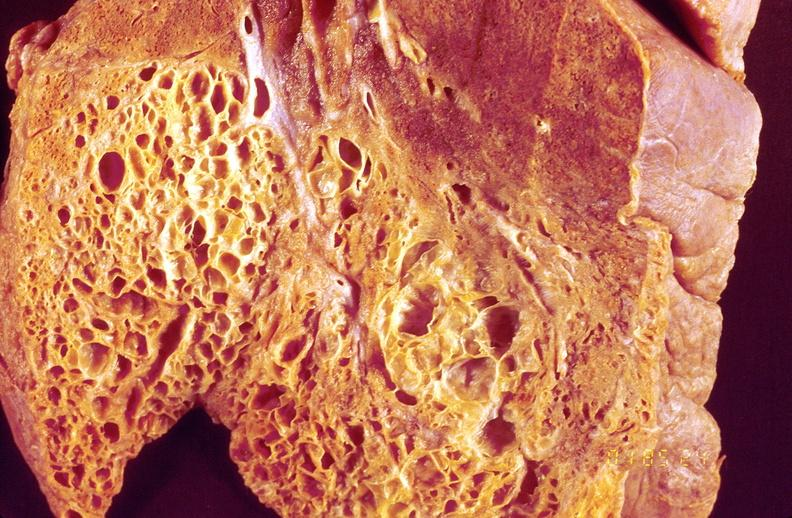where is this?
Answer the question using a single word or phrase. Lung 